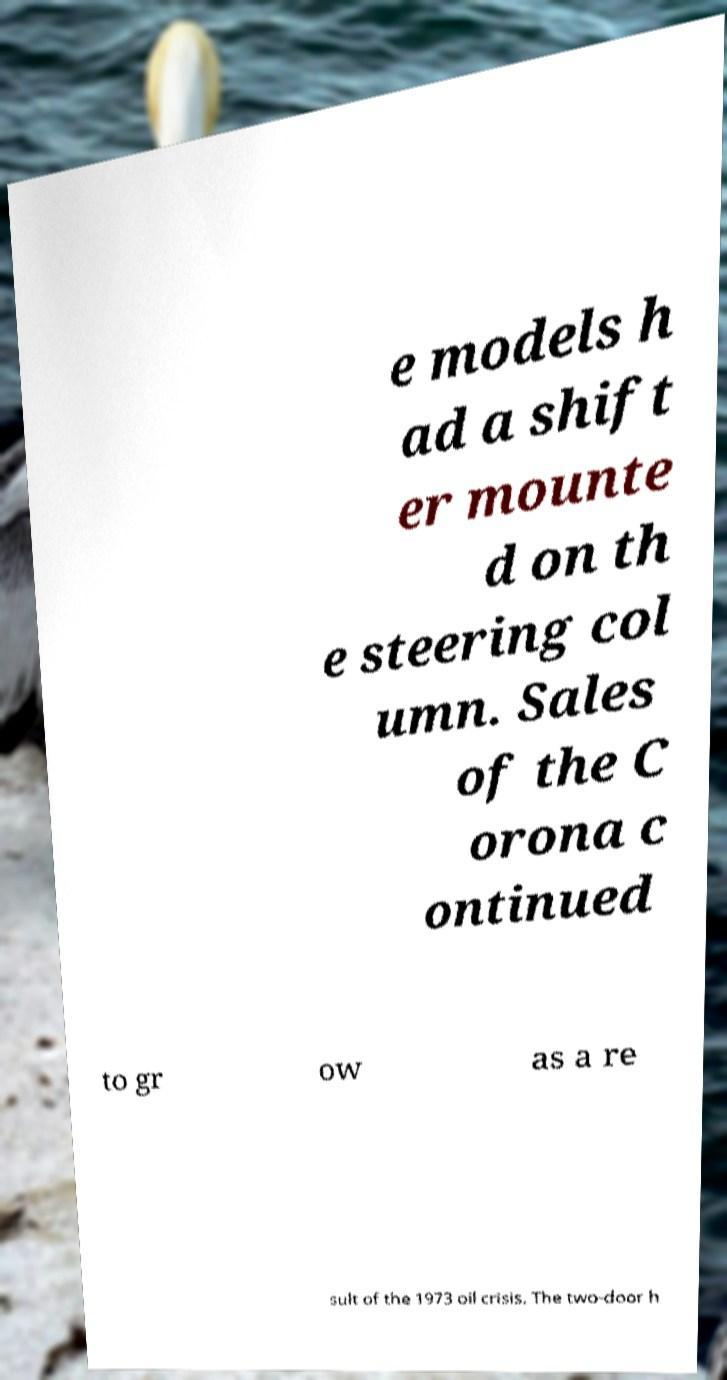Please read and relay the text visible in this image. What does it say? e models h ad a shift er mounte d on th e steering col umn. Sales of the C orona c ontinued to gr ow as a re sult of the 1973 oil crisis. The two-door h 